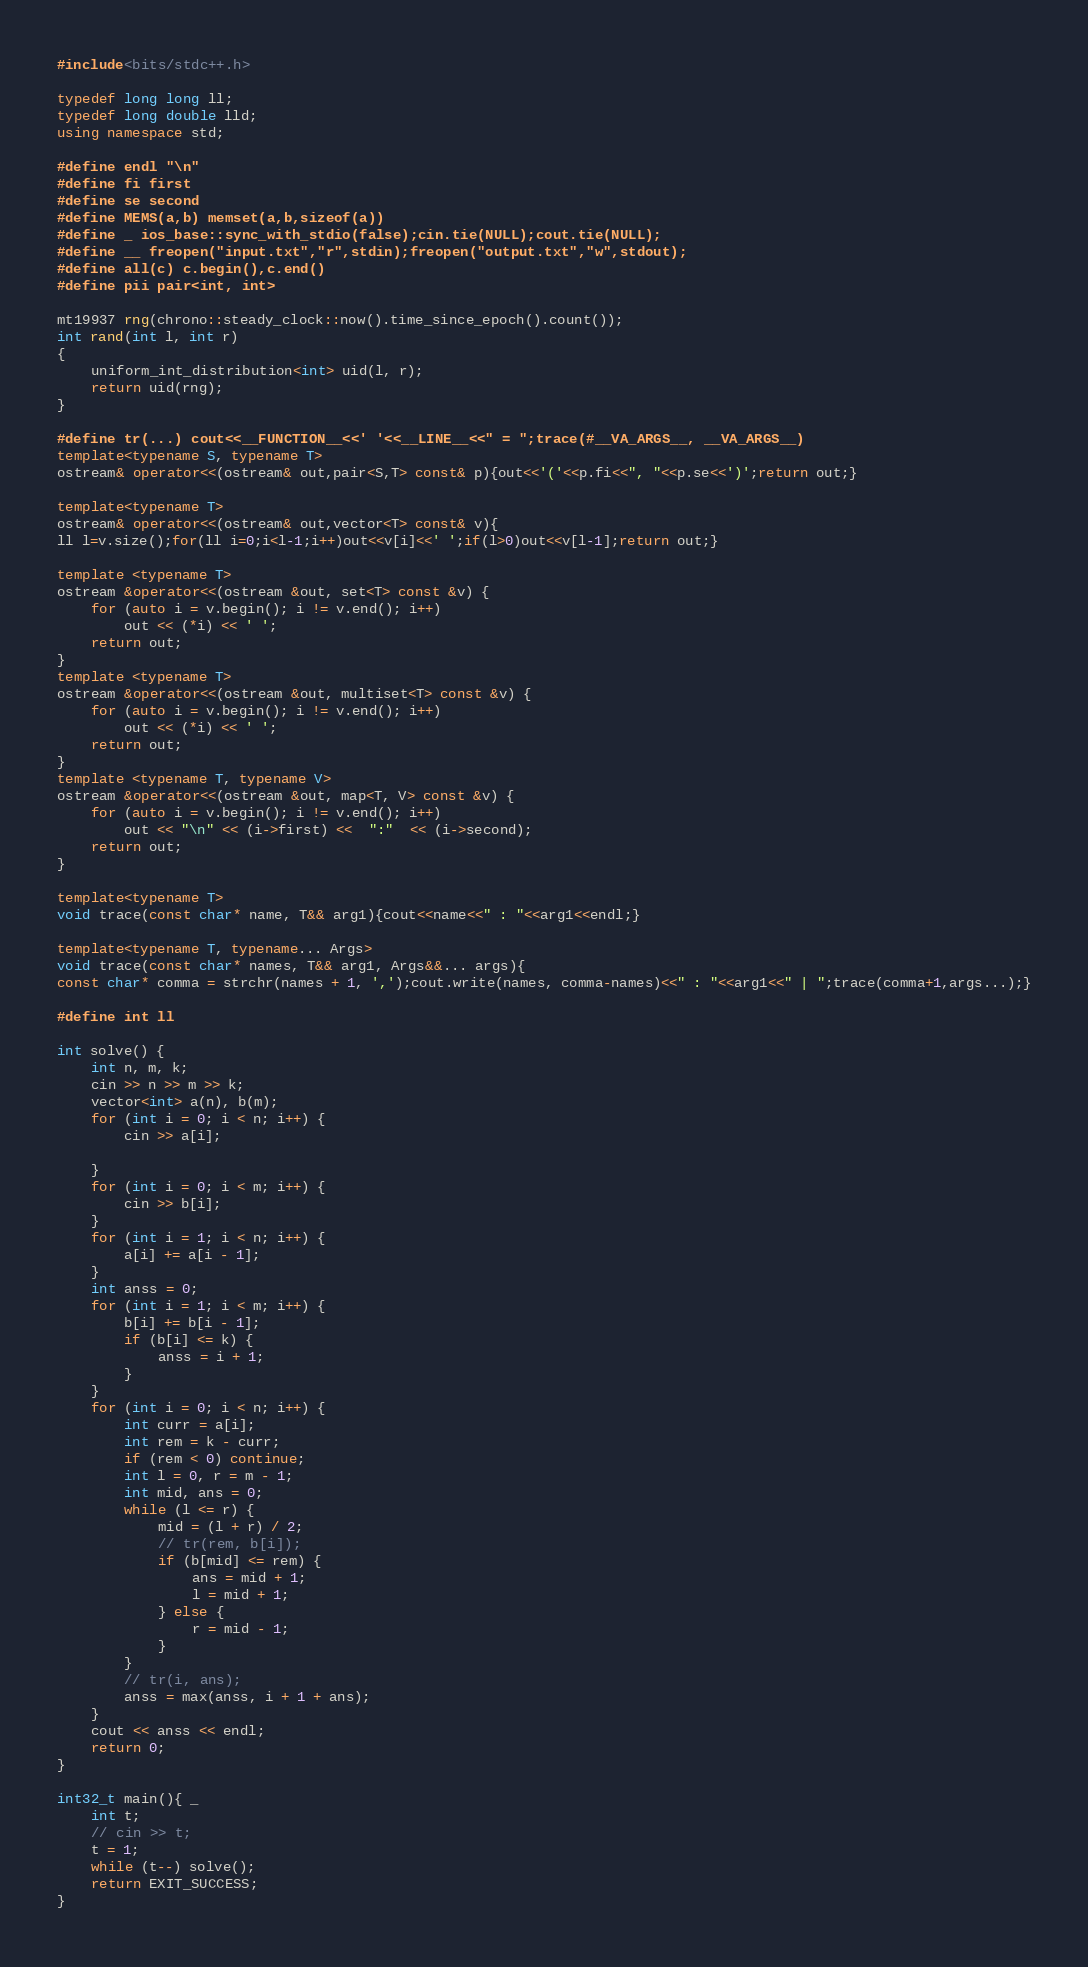<code> <loc_0><loc_0><loc_500><loc_500><_C++_>#include<bits/stdc++.h>

typedef long long ll;
typedef long double lld;
using namespace std;

#define endl "\n"
#define fi first
#define se second
#define MEMS(a,b) memset(a,b,sizeof(a))
#define _ ios_base::sync_with_stdio(false);cin.tie(NULL);cout.tie(NULL);
#define __ freopen("input.txt","r",stdin);freopen("output.txt","w",stdout);
#define all(c) c.begin(),c.end()
#define pii pair<int, int>

mt19937 rng(chrono::steady_clock::now().time_since_epoch().count());
int rand(int l, int r)
{
	uniform_int_distribution<int> uid(l, r);
	return uid(rng);
}

#define tr(...) cout<<__FUNCTION__<<' '<<__LINE__<<" = ";trace(#__VA_ARGS__, __VA_ARGS__)
template<typename S, typename T>
ostream& operator<<(ostream& out,pair<S,T> const& p){out<<'('<<p.fi<<", "<<p.se<<')';return out;}

template<typename T>
ostream& operator<<(ostream& out,vector<T> const& v){
ll l=v.size();for(ll i=0;i<l-1;i++)out<<v[i]<<' ';if(l>0)out<<v[l-1];return out;}

template <typename T>
ostream &operator<<(ostream &out, set<T> const &v) {
    for (auto i = v.begin(); i != v.end(); i++)
        out << (*i) << ' ';
    return out;
}
template <typename T>
ostream &operator<<(ostream &out, multiset<T> const &v) {
    for (auto i = v.begin(); i != v.end(); i++)
        out << (*i) << ' ';
    return out;
}
template <typename T, typename V>
ostream &operator<<(ostream &out, map<T, V> const &v) {
    for (auto i = v.begin(); i != v.end(); i++)
        out << "\n" << (i->first) <<  ":"  << (i->second);
    return out;
}

template<typename T>
void trace(const char* name, T&& arg1){cout<<name<<" : "<<arg1<<endl;}

template<typename T, typename... Args>
void trace(const char* names, T&& arg1, Args&&... args){
const char* comma = strchr(names + 1, ',');cout.write(names, comma-names)<<" : "<<arg1<<" | ";trace(comma+1,args...);}

#define int ll

int solve() {
    int n, m, k;
    cin >> n >> m >> k;
    vector<int> a(n), b(m);
    for (int i = 0; i < n; i++) {
        cin >> a[i];

    }
    for (int i = 0; i < m; i++) {
        cin >> b[i];
    }
    for (int i = 1; i < n; i++) {
        a[i] += a[i - 1];
    }
    int anss = 0;
    for (int i = 1; i < m; i++) {
        b[i] += b[i - 1];
        if (b[i] <= k) {
            anss = i + 1;
        }
    }
    for (int i = 0; i < n; i++) {
        int curr = a[i];
        int rem = k - curr;
        if (rem < 0) continue;
        int l = 0, r = m - 1;
        int mid, ans = 0;
        while (l <= r) {
            mid = (l + r) / 2;
            // tr(rem, b[i]);
            if (b[mid] <= rem) {
                ans = mid + 1;
                l = mid + 1;
            } else {
                r = mid - 1;
            }
        }
        // tr(i, ans);
        anss = max(anss, i + 1 + ans);
    }
    cout << anss << endl;
    return 0;
}

int32_t main(){ _
    int t;
    // cin >> t;
    t = 1;
    while (t--) solve();
    return EXIT_SUCCESS;	
}
</code> 